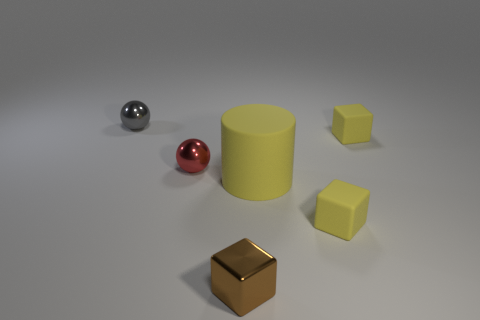What number of things are small things in front of the yellow rubber cylinder or tiny matte objects in front of the large yellow matte cylinder?
Make the answer very short. 2. Does the gray metal object have the same shape as the yellow object that is in front of the large yellow rubber cylinder?
Give a very brief answer. No. How many other objects are there of the same shape as the gray object?
Your response must be concise. 1. How many objects are either red metal spheres or small rubber blocks?
Give a very brief answer. 3. Is the color of the big matte cylinder the same as the metal cube?
Give a very brief answer. No. Are there any other things that are the same size as the rubber cylinder?
Your answer should be compact. No. There is a tiny yellow matte thing that is on the left side of the tiny yellow rubber block behind the large yellow thing; what shape is it?
Your answer should be compact. Cube. Are there fewer big brown rubber objects than red balls?
Ensure brevity in your answer.  Yes. Do the brown thing and the gray ball have the same size?
Offer a terse response. Yes. Do the tiny matte block behind the yellow cylinder and the cylinder have the same color?
Your response must be concise. Yes. 